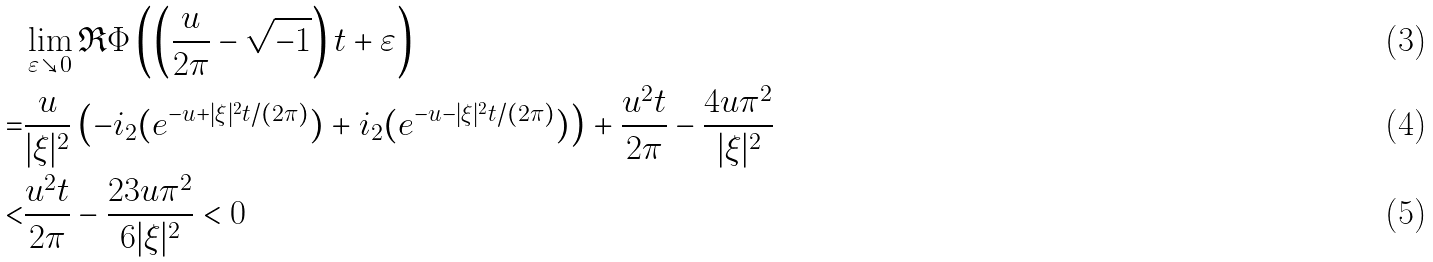Convert formula to latex. <formula><loc_0><loc_0><loc_500><loc_500>& \lim _ { \varepsilon \searrow 0 } \Re \Phi \left ( \left ( \frac { u } { 2 \pi } - \sqrt { - 1 } \right ) t + \varepsilon \right ) \\ = & \frac { u } { | \xi | ^ { 2 } } \left ( - \L i _ { 2 } ( e ^ { - u + | \xi | ^ { 2 } t / ( 2 \pi ) } ) + \L i _ { 2 } ( e ^ { - u - | \xi | ^ { 2 } t / ( 2 \pi ) } ) \right ) + \frac { u ^ { 2 } t } { 2 \pi } - \frac { 4 u \pi ^ { 2 } } { | \xi | ^ { 2 } } \\ < & \frac { u ^ { 2 } t } { 2 \pi } - \frac { 2 3 u \pi ^ { 2 } } { 6 | \xi | ^ { 2 } } < 0</formula> 